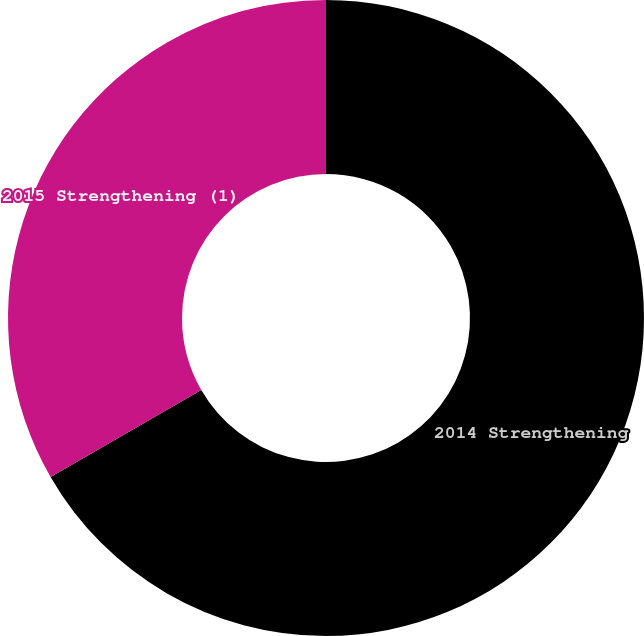Convert chart to OTSL. <chart><loc_0><loc_0><loc_500><loc_500><pie_chart><fcel>2014 Strengthening<fcel>2015 Strengthening (1)<nl><fcel>66.67%<fcel>33.33%<nl></chart> 